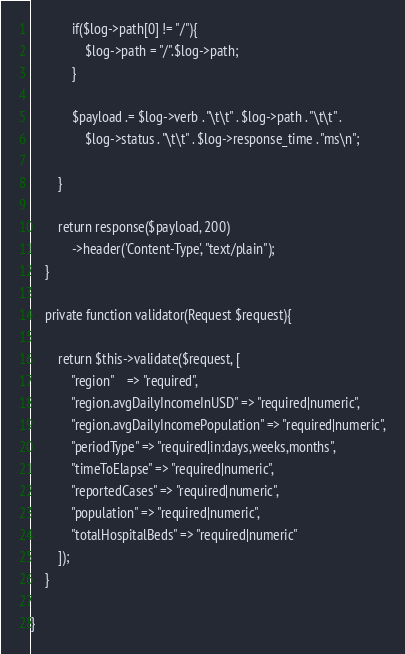Convert code to text. <code><loc_0><loc_0><loc_500><loc_500><_PHP_>
            if($log->path[0] != "/"){
                $log->path = "/".$log->path;
            }

            $payload .= $log->verb . "\t\t" . $log->path . "\t\t" .
                $log->status . "\t\t" . $log->response_time . "ms\n";

        }

        return response($payload, 200)
            ->header('Content-Type', "text/plain");
    }

    private function validator(Request $request){

        return $this->validate($request, [
            "region"    => "required",
            "region.avgDailyIncomeInUSD" => "required|numeric",
            "region.avgDailyIncomePopulation" => "required|numeric",
            "periodType" => "required|in:days,weeks,months",
            "timeToElapse" => "required|numeric",
            "reportedCases" => "required|numeric",
            "population" => "required|numeric",
            "totalHospitalBeds" => "required|numeric"
        ]);
    }

}
</code> 